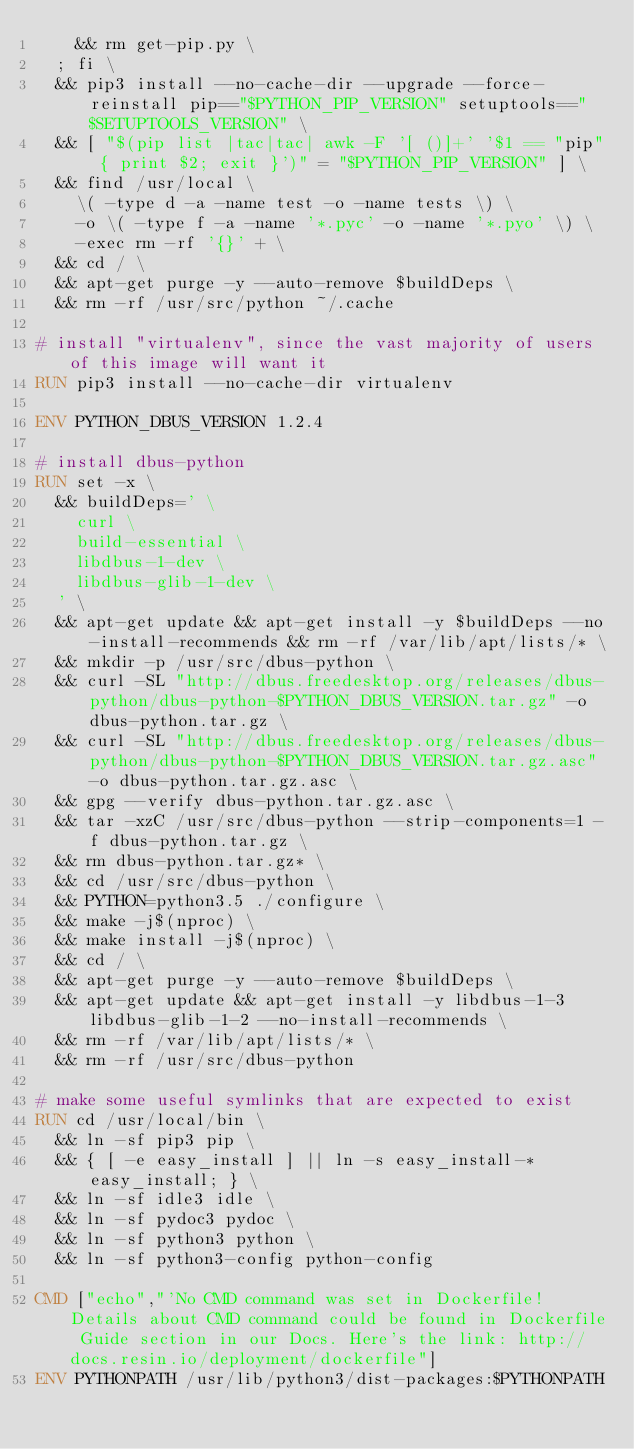Convert code to text. <code><loc_0><loc_0><loc_500><loc_500><_Dockerfile_>		&& rm get-pip.py \
	; fi \
	&& pip3 install --no-cache-dir --upgrade --force-reinstall pip=="$PYTHON_PIP_VERSION" setuptools=="$SETUPTOOLS_VERSION" \
	&& [ "$(pip list |tac|tac| awk -F '[ ()]+' '$1 == "pip" { print $2; exit }')" = "$PYTHON_PIP_VERSION" ] \
	&& find /usr/local \
		\( -type d -a -name test -o -name tests \) \
		-o \( -type f -a -name '*.pyc' -o -name '*.pyo' \) \
		-exec rm -rf '{}' + \
	&& cd / \
	&& apt-get purge -y --auto-remove $buildDeps \
	&& rm -rf /usr/src/python ~/.cache

# install "virtualenv", since the vast majority of users of this image will want it
RUN pip3 install --no-cache-dir virtualenv

ENV PYTHON_DBUS_VERSION 1.2.4

# install dbus-python
RUN set -x \
	&& buildDeps=' \
		curl \
		build-essential \
		libdbus-1-dev \
		libdbus-glib-1-dev \
	' \
	&& apt-get update && apt-get install -y $buildDeps --no-install-recommends && rm -rf /var/lib/apt/lists/* \
	&& mkdir -p /usr/src/dbus-python \
	&& curl -SL "http://dbus.freedesktop.org/releases/dbus-python/dbus-python-$PYTHON_DBUS_VERSION.tar.gz" -o dbus-python.tar.gz \
	&& curl -SL "http://dbus.freedesktop.org/releases/dbus-python/dbus-python-$PYTHON_DBUS_VERSION.tar.gz.asc" -o dbus-python.tar.gz.asc \
	&& gpg --verify dbus-python.tar.gz.asc \
	&& tar -xzC /usr/src/dbus-python --strip-components=1 -f dbus-python.tar.gz \
	&& rm dbus-python.tar.gz* \
	&& cd /usr/src/dbus-python \
	&& PYTHON=python3.5 ./configure \
	&& make -j$(nproc) \
	&& make install -j$(nproc) \
	&& cd / \
	&& apt-get purge -y --auto-remove $buildDeps \
	&& apt-get update && apt-get install -y libdbus-1-3 libdbus-glib-1-2 --no-install-recommends \
	&& rm -rf /var/lib/apt/lists/* \
	&& rm -rf /usr/src/dbus-python

# make some useful symlinks that are expected to exist
RUN cd /usr/local/bin \
	&& ln -sf pip3 pip \
	&& { [ -e easy_install ] || ln -s easy_install-* easy_install; } \
	&& ln -sf idle3 idle \
	&& ln -sf pydoc3 pydoc \
	&& ln -sf python3 python \
	&& ln -sf python3-config python-config

CMD ["echo","'No CMD command was set in Dockerfile! Details about CMD command could be found in Dockerfile Guide section in our Docs. Here's the link: http://docs.resin.io/deployment/dockerfile"]
ENV PYTHONPATH /usr/lib/python3/dist-packages:$PYTHONPATH
</code> 